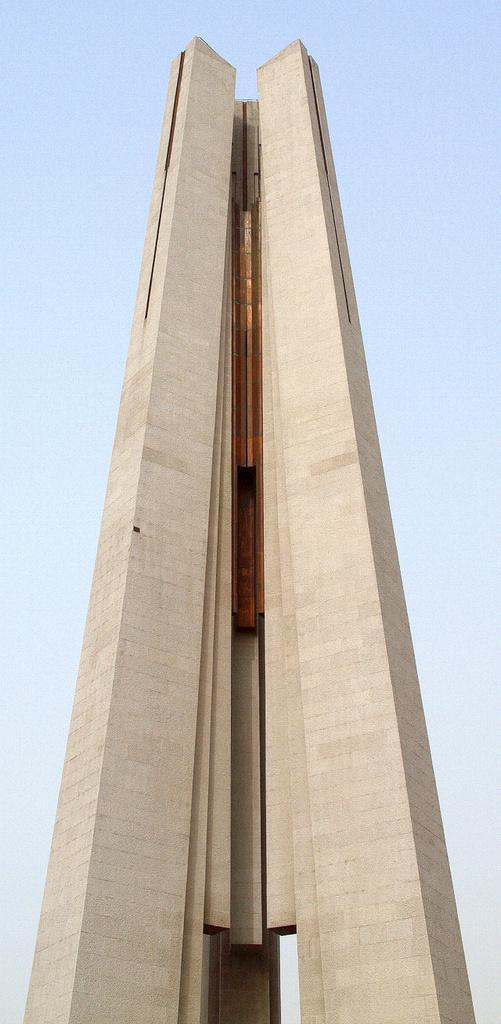Could you give a brief overview of what you see in this image? In this image I can see a building in the centre and in the background I can see the sky. 